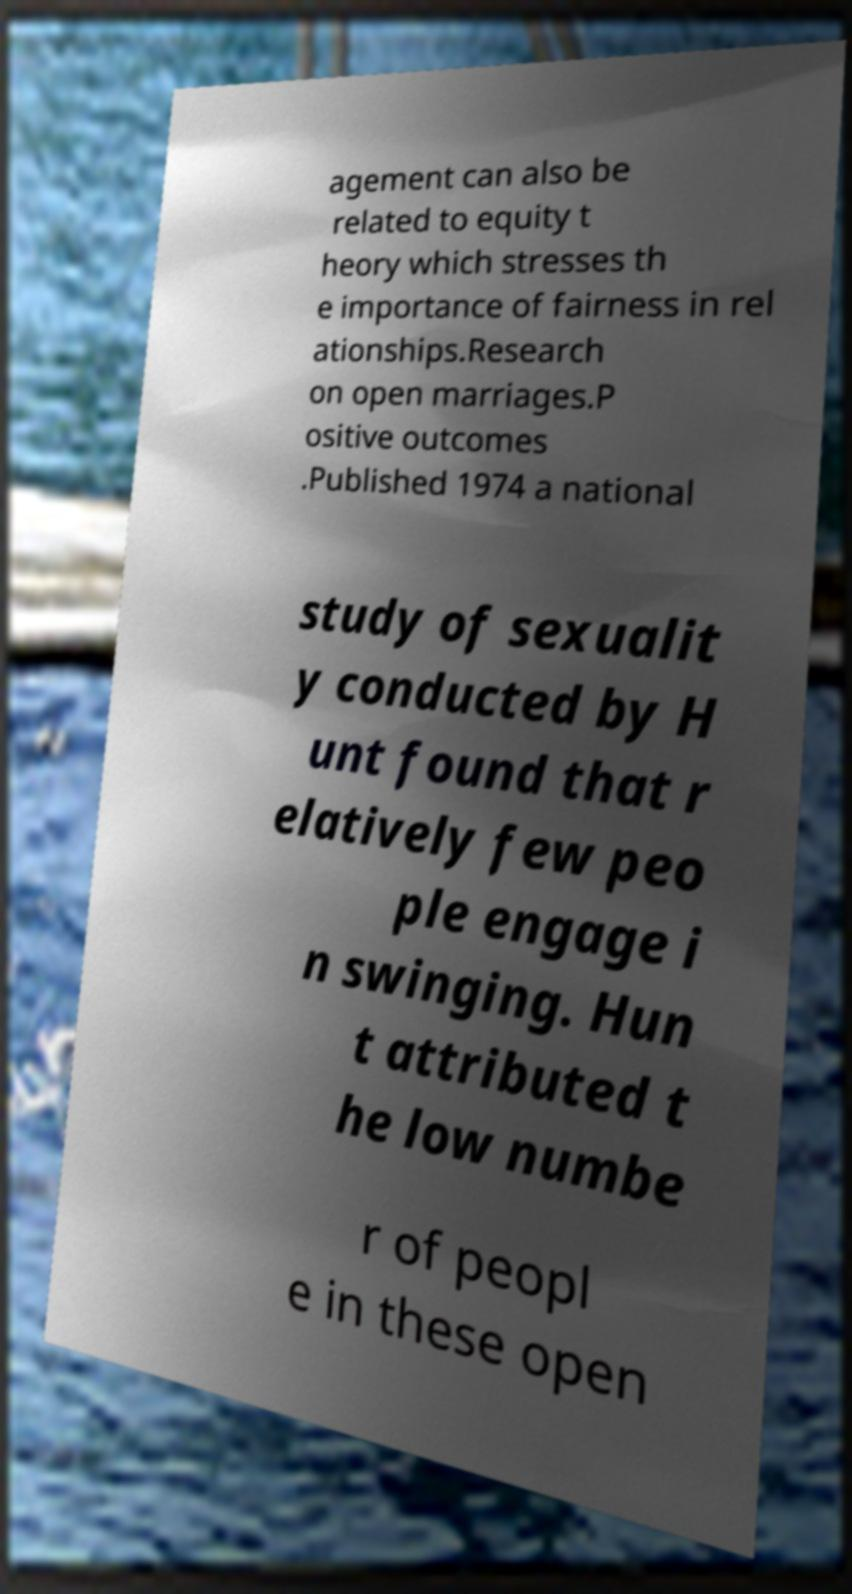Could you extract and type out the text from this image? agement can also be related to equity t heory which stresses th e importance of fairness in rel ationships.Research on open marriages.P ositive outcomes .Published 1974 a national study of sexualit y conducted by H unt found that r elatively few peo ple engage i n swinging. Hun t attributed t he low numbe r of peopl e in these open 